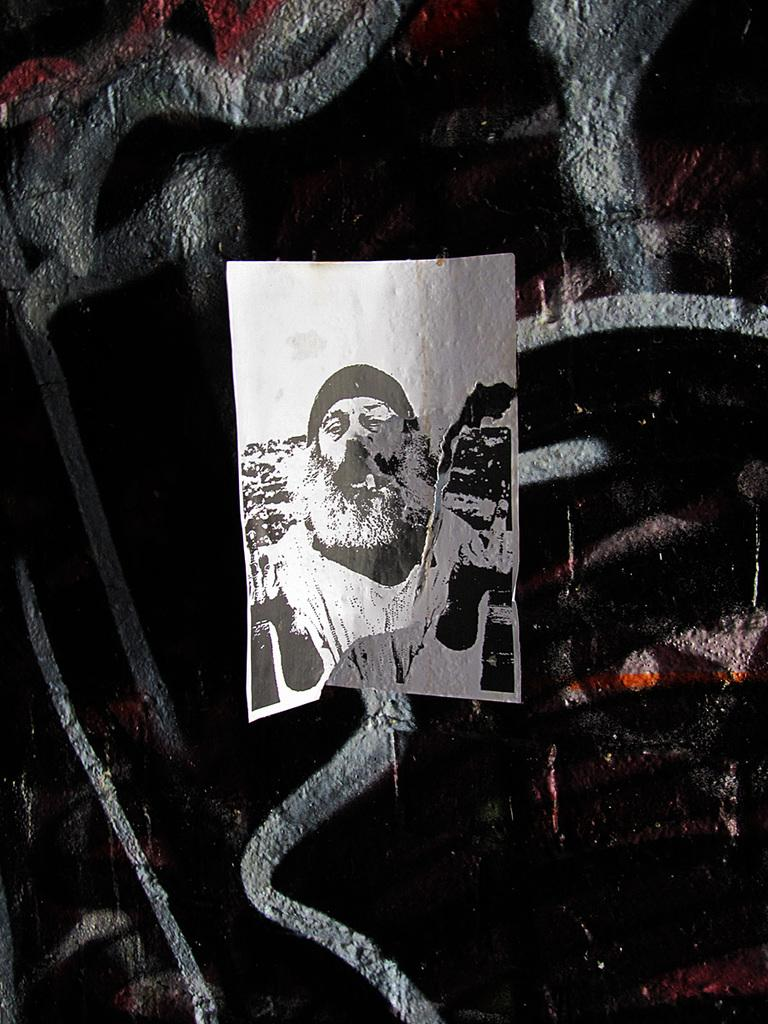What color scheme is used in the picture? The picture is white and black. What material is the picture placed on? The picture is on a cloth. What type of disease is depicted in the picture? There is no disease depicted in the picture, as it is a white and black image on a cloth. Can you tell me how many fangs are visible in the picture? There are no fangs present in the picture, as it is a white and black image on a cloth. 